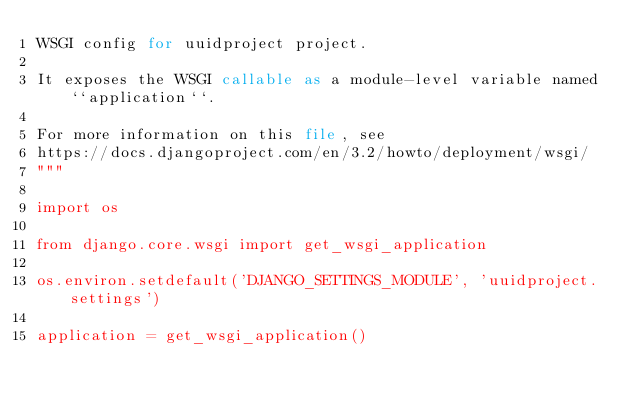Convert code to text. <code><loc_0><loc_0><loc_500><loc_500><_Python_>WSGI config for uuidproject project.

It exposes the WSGI callable as a module-level variable named ``application``.

For more information on this file, see
https://docs.djangoproject.com/en/3.2/howto/deployment/wsgi/
"""

import os

from django.core.wsgi import get_wsgi_application

os.environ.setdefault('DJANGO_SETTINGS_MODULE', 'uuidproject.settings')

application = get_wsgi_application()
</code> 